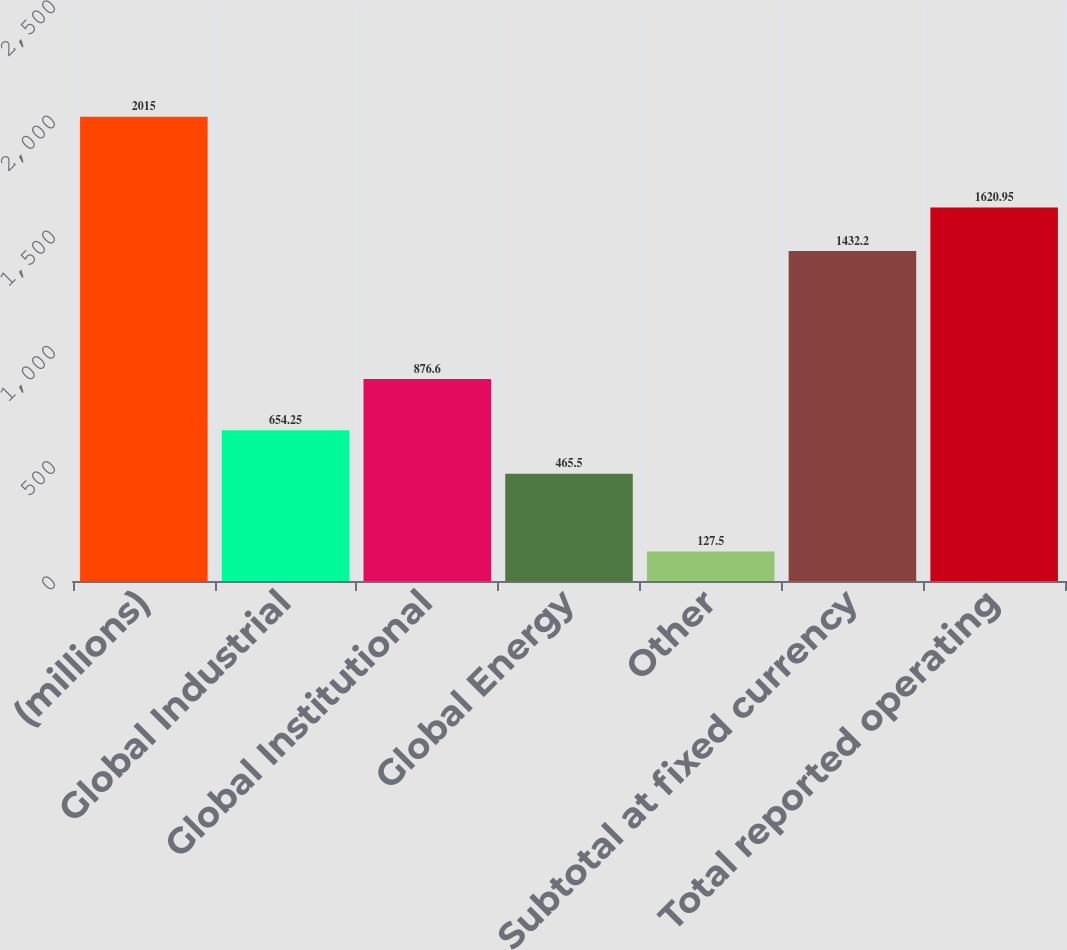Convert chart to OTSL. <chart><loc_0><loc_0><loc_500><loc_500><bar_chart><fcel>(millions)<fcel>Global Industrial<fcel>Global Institutional<fcel>Global Energy<fcel>Other<fcel>Subtotal at fixed currency<fcel>Total reported operating<nl><fcel>2015<fcel>654.25<fcel>876.6<fcel>465.5<fcel>127.5<fcel>1432.2<fcel>1620.95<nl></chart> 